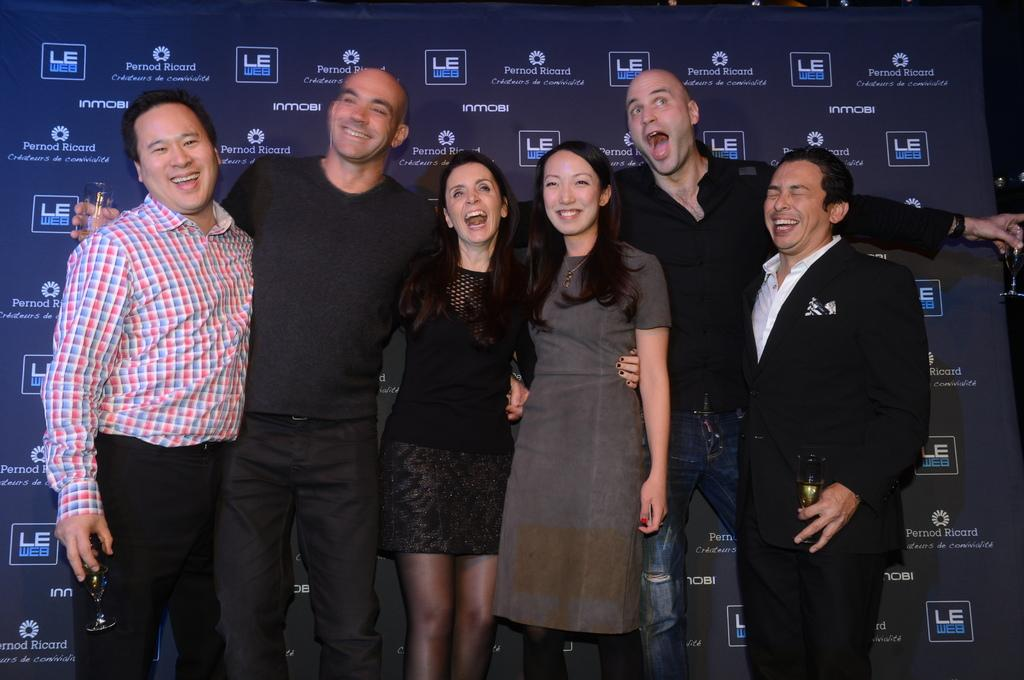What is happening in the image involving a group of people? In the image, there is a group of people standing and holding each other. Are there any objects being held by the people in the group? Yes, some people in the group are holding glasses. What can be seen in the background of the image? There is a board with text on it in the background of the image. What type of pest is causing trouble for the people in the image? There is no pest or trouble mentioned in the image; it simply shows a group of people standing and holding each other. Can you see any scissors being used by the people in the image? There is no mention of scissors in the image; the people are holding each other and some are holding glasses. 